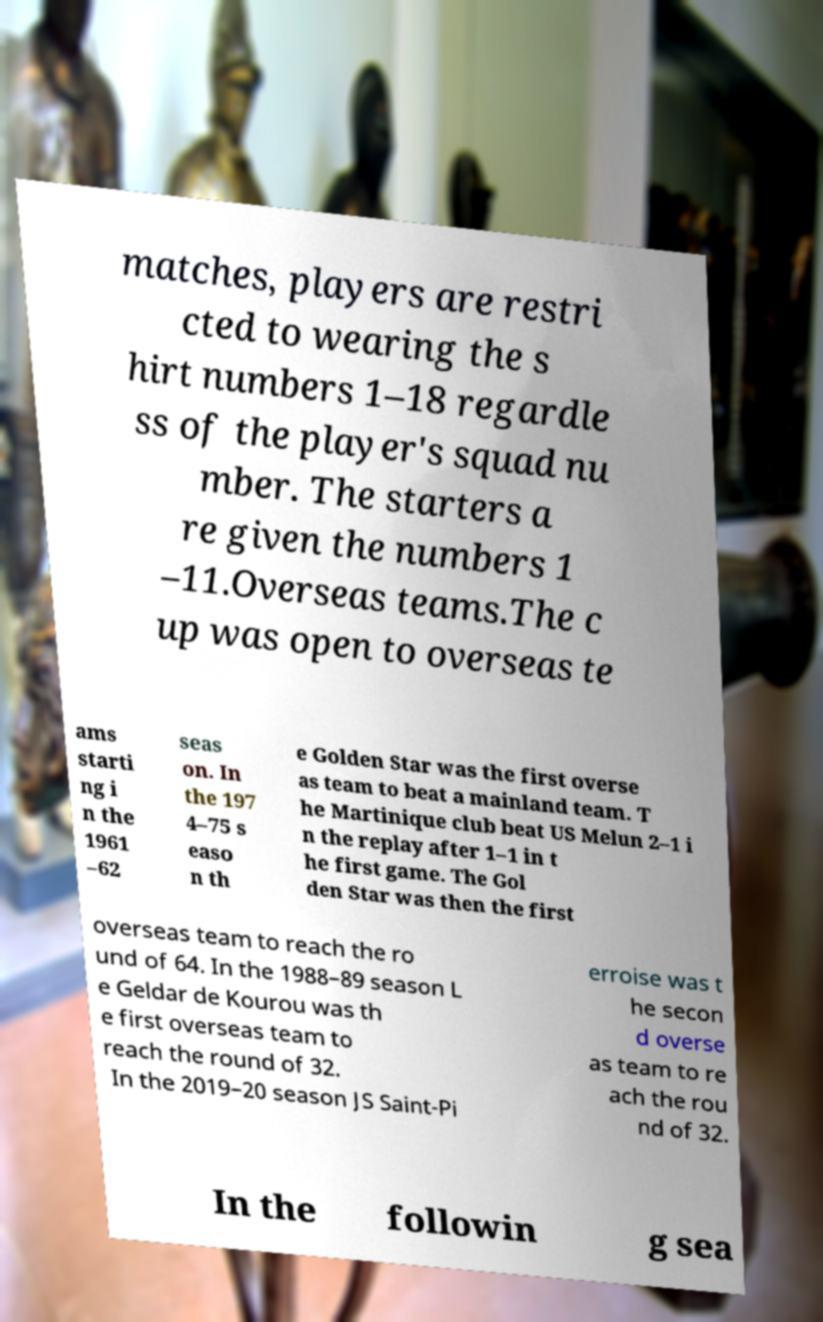Could you assist in decoding the text presented in this image and type it out clearly? matches, players are restri cted to wearing the s hirt numbers 1–18 regardle ss of the player's squad nu mber. The starters a re given the numbers 1 –11.Overseas teams.The c up was open to overseas te ams starti ng i n the 1961 –62 seas on. In the 197 4–75 s easo n th e Golden Star was the first overse as team to beat a mainland team. T he Martinique club beat US Melun 2–1 i n the replay after 1–1 in t he first game. The Gol den Star was then the first overseas team to reach the ro und of 64. In the 1988–89 season L e Geldar de Kourou was th e first overseas team to reach the round of 32. In the 2019–20 season JS Saint-Pi erroise was t he secon d overse as team to re ach the rou nd of 32. In the followin g sea 